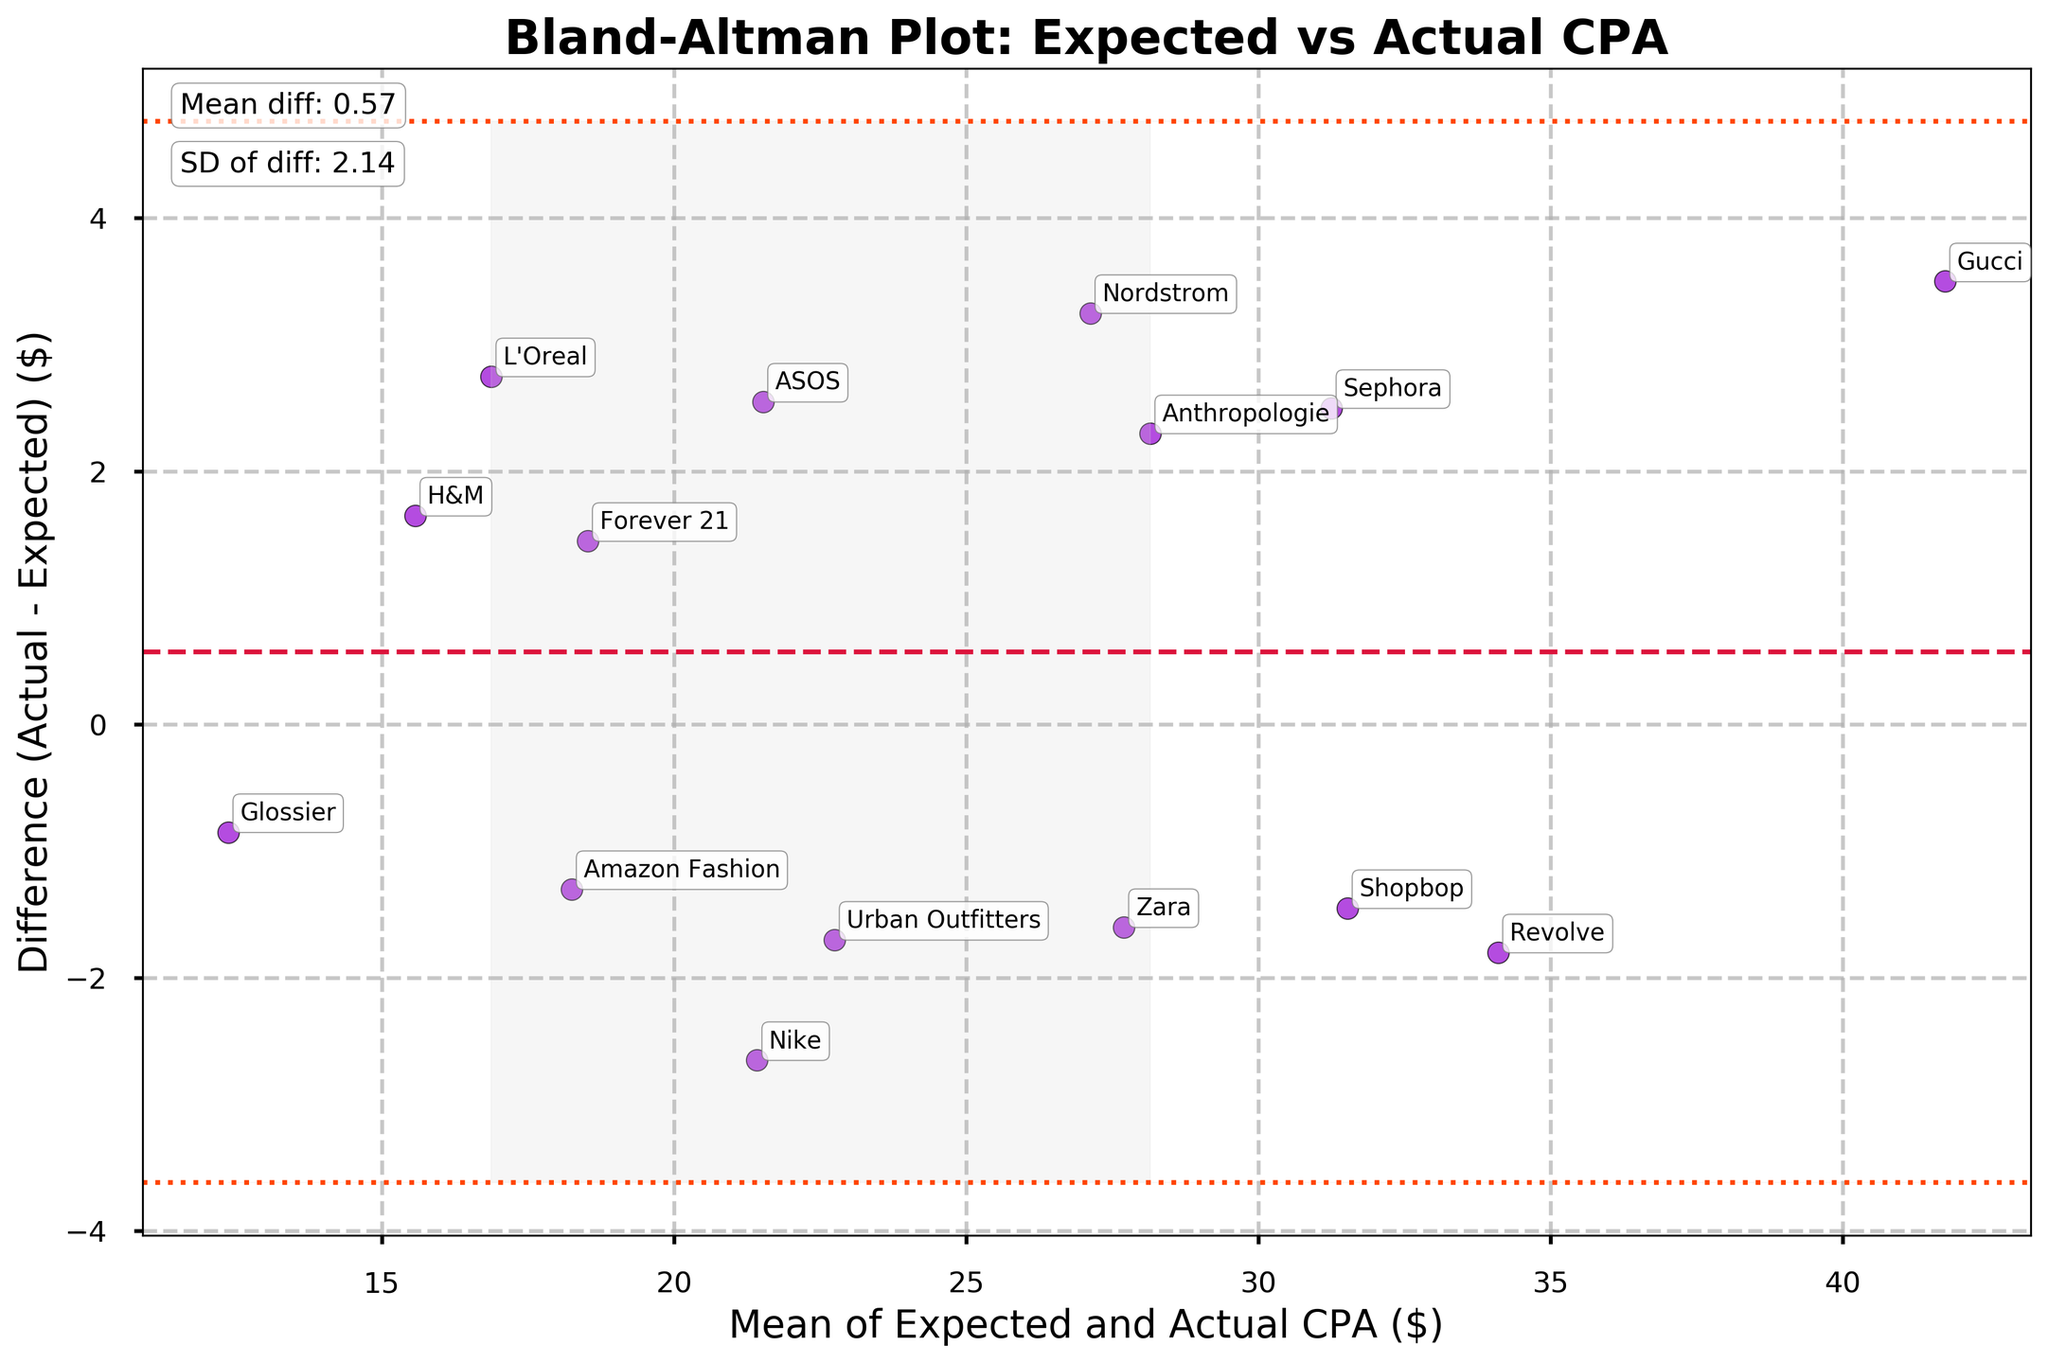Which brand has the highest actual CPA? To find the highest actual CPA, look at all the values on the y-axis (Actual CPA) and identify the largest number. Gucci has the highest actual CPA at $43.50.
Answer: Gucci What is the mean difference between actual and expected CPA? The mean difference (md) is indicated on the plot by the red dashed line; it is also mentioned as text on the figure. The mean difference is $0.45.
Answer: 0.45 How many points fall within the limits of agreement? The limits of agreement are the lines at md ± 1.96*sd. Count how many points fall between these two lines. All data points fall within the limits of agreement.
Answer: 15 Which brand has the largest difference between actual and expected CPA? To find this, identify the point on the plot with the largest distance from the mean difference line. Gucci has the largest difference ($3.50).
Answer: Gucci What is the standard deviation of the differences? The standard deviation (sd) is indicated on the plot as text near the bottom, right above the limits of agreement. The standard deviation of the differences is $1.87.
Answer: 1.87 Which brand shows the closest actual CPA to its expected CPA? The closest actual CPA to expected CPA would have the smallest difference. Glossier has the smallest difference ($0.85).
Answer: Glossier What does the shaded area on the plot indicate? The shaded area represents the limits of agreement, which are the range within md ± 1.96*sd.
Answer: Limits of agreement What is the range of the mean CPA values (Expected and Actual) on the x-axis? Look at the x-axis to find the minimum and maximum mean values of CPA. The range of mean CPA values on the x-axis is from about $12 to $39.
Answer: 12 to 39 Which brands have actual CPA values greater than the expected CPA values? Points above the mean difference line indicate that the actual CPA is greater than expected. The brands are L'Oreal, Sephora, Nordstrom, ASOS, H&M, Gucci, Forever 21, and Anthropologie.
Answer: L'Oreal, Sephora, Nordstrom, ASOS, H&M, Gucci, Forever 21, Anthropologie 